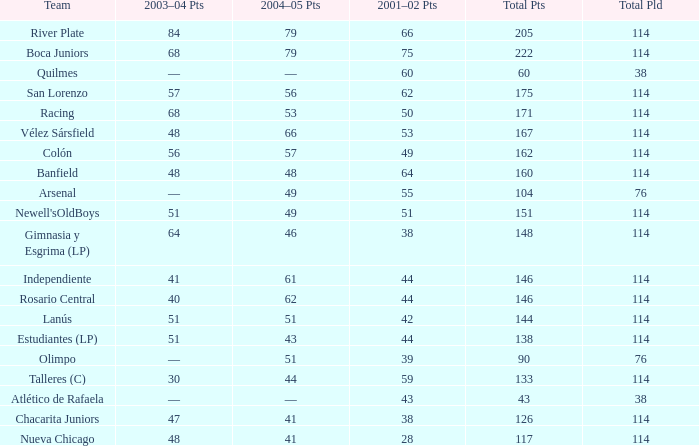In the 2001-02 season, which total points are less than 38? 117.0. 